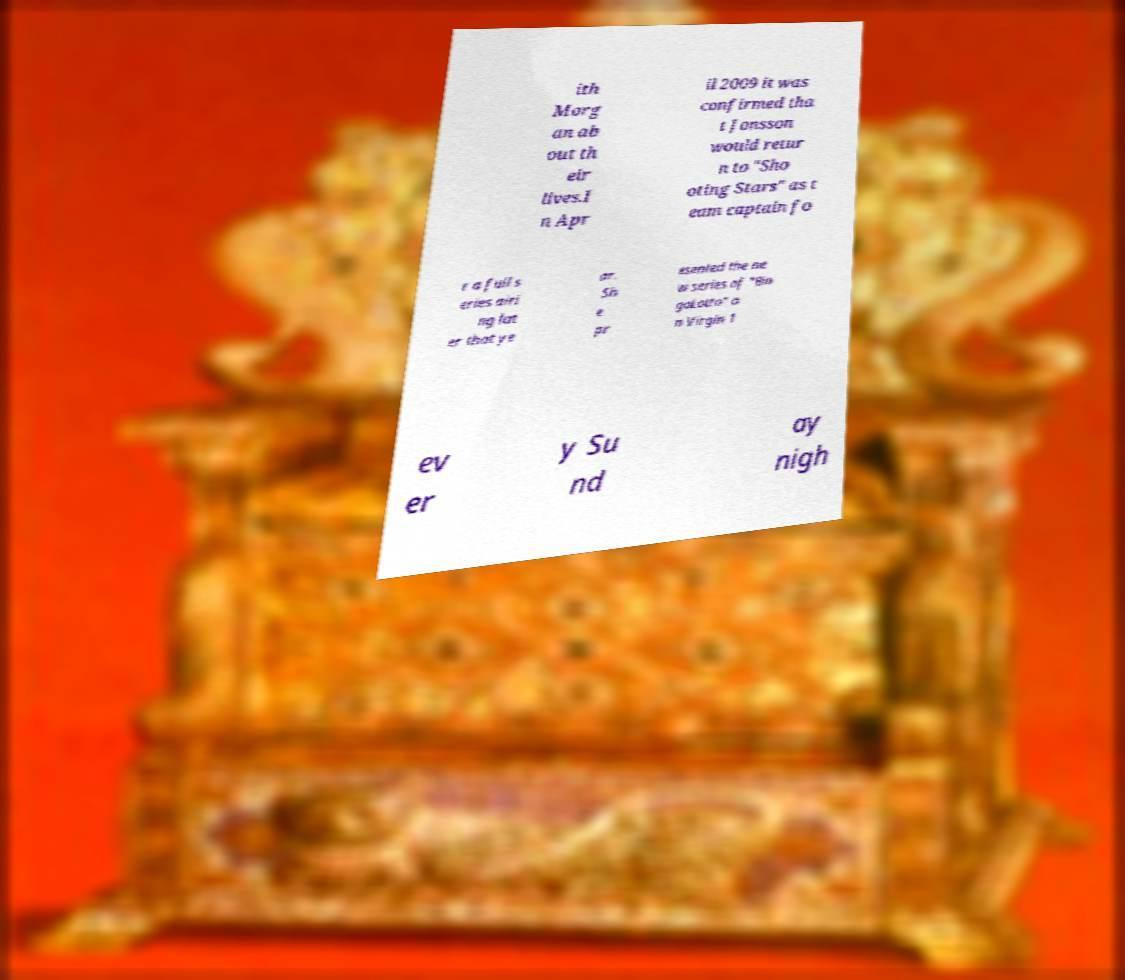I need the written content from this picture converted into text. Can you do that? ith Morg an ab out th eir lives.I n Apr il 2009 it was confirmed tha t Jonsson would retur n to "Sho oting Stars" as t eam captain fo r a full s eries airi ng lat er that ye ar. Sh e pr esented the ne w series of "Bin goLotto" o n Virgin 1 ev er y Su nd ay nigh 